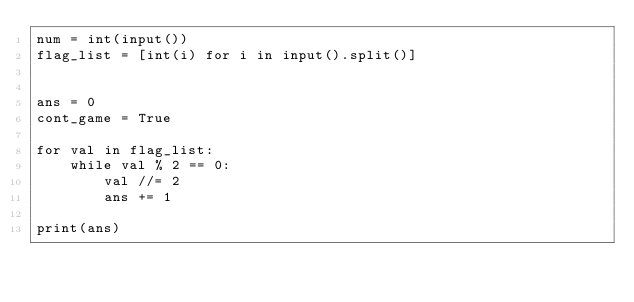<code> <loc_0><loc_0><loc_500><loc_500><_Python_>num = int(input())
flag_list = [int(i) for i in input().split()]


ans = 0
cont_game = True

for val in flag_list:
    while val % 2 == 0:
        val //= 2
        ans += 1

print(ans)</code> 